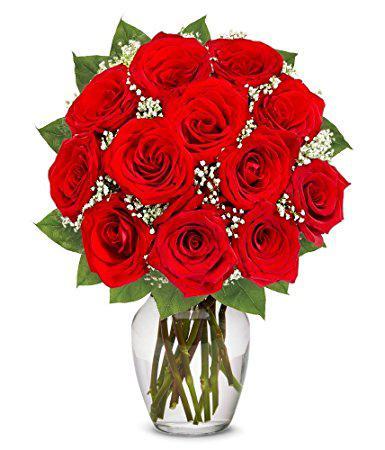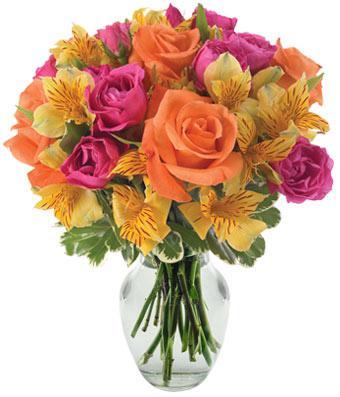The first image is the image on the left, the second image is the image on the right. Analyze the images presented: Is the assertion "No vase includes only roses, and at least one vase is decorated with a ribbon tied in a bow." valid? Answer yes or no. No. The first image is the image on the left, the second image is the image on the right. Evaluate the accuracy of this statement regarding the images: "There is a bow around the vase in the image on the right.". Is it true? Answer yes or no. No. 